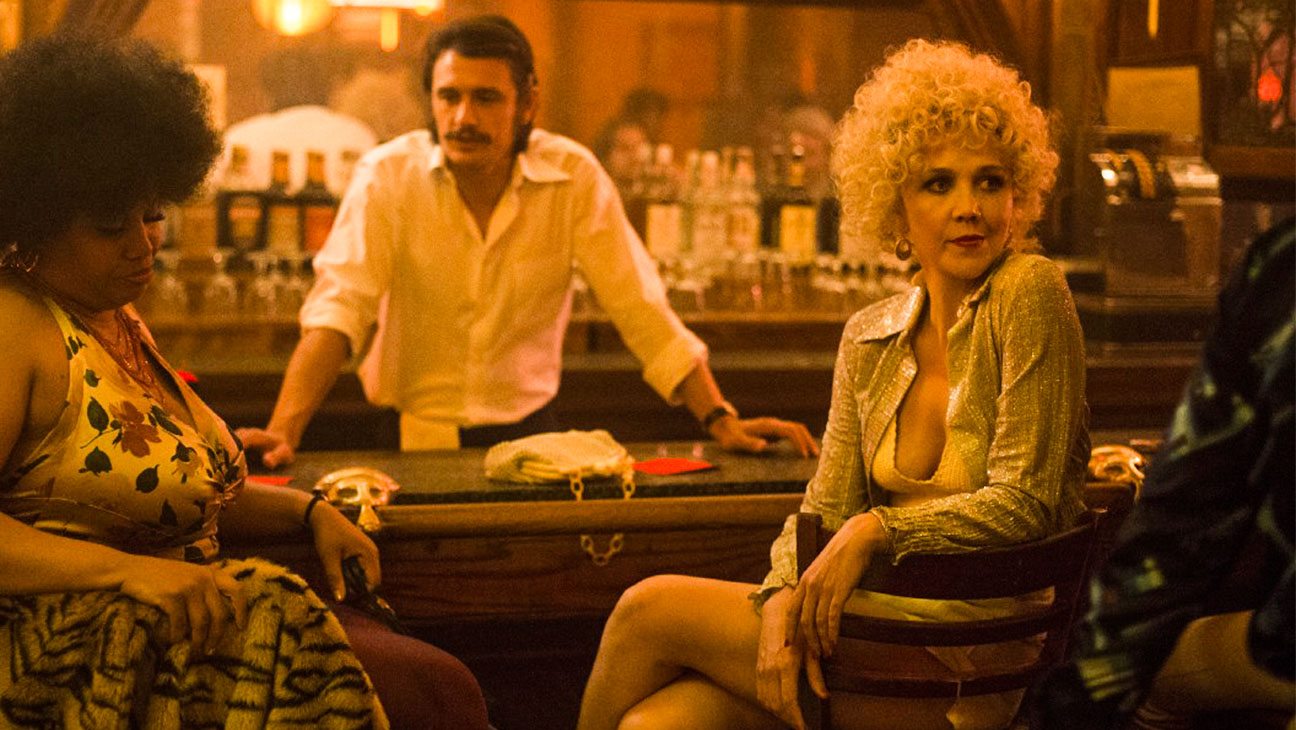Can you describe the mood or atmosphere of this scene? The mood of the scene is evocative of a classic, somewhat melancholic bar atmosphere. The subdued lighting and rich, warm tones create a sense of intimacy and a hint of mystery. Each character appears absorbed in their own world, adding to the layered, contemplative feel of the setting. How might the choice of lighting influence the viewer's perception of this scene? The choice of dim, warm lighting draws the viewer's focus to the central character, while casting shadows that add depth and intrigue. It evokes a sense of nostalgia and drama, making the scene appear more intimate and emotionally charged. This kind of lighting technique is often used to enhance storytelling by creating a specific mood that aligns with the narrative's tone. 